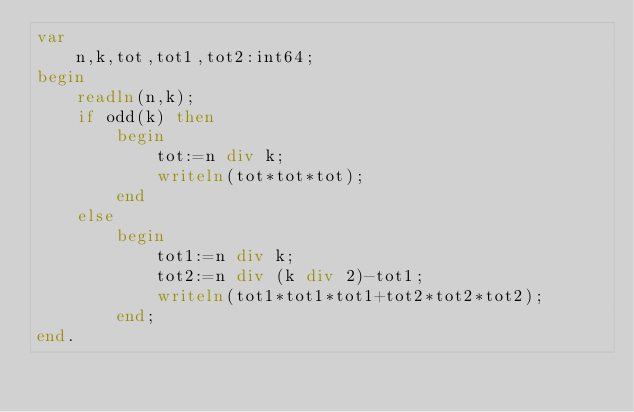Convert code to text. <code><loc_0><loc_0><loc_500><loc_500><_Pascal_>var
    n,k,tot,tot1,tot2:int64;
begin
    readln(n,k);
    if odd(k) then 
        begin
            tot:=n div k;
            writeln(tot*tot*tot);
        end
    else
        begin
            tot1:=n div k;
            tot2:=n div (k div 2)-tot1;
            writeln(tot1*tot1*tot1+tot2*tot2*tot2);
        end;
end.</code> 